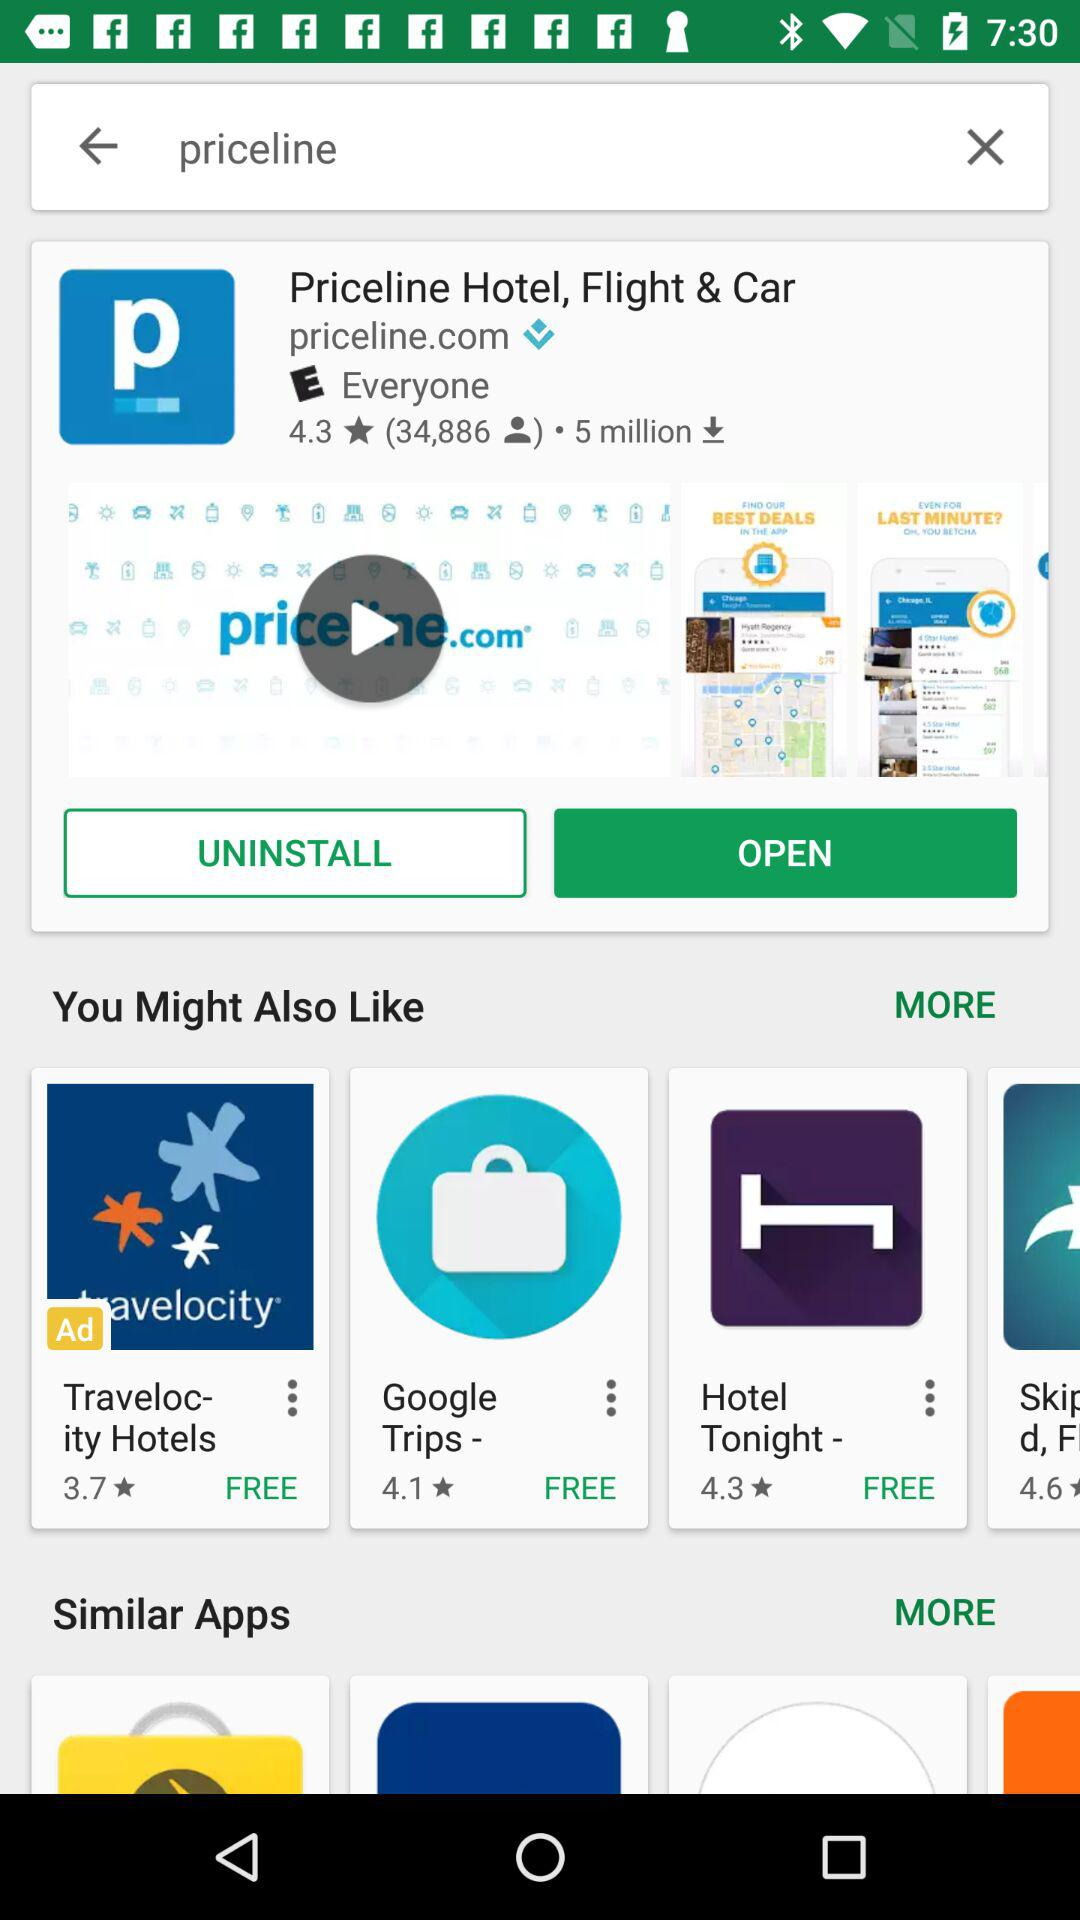How many downloads have been made? There have been 5 million downloads made. 